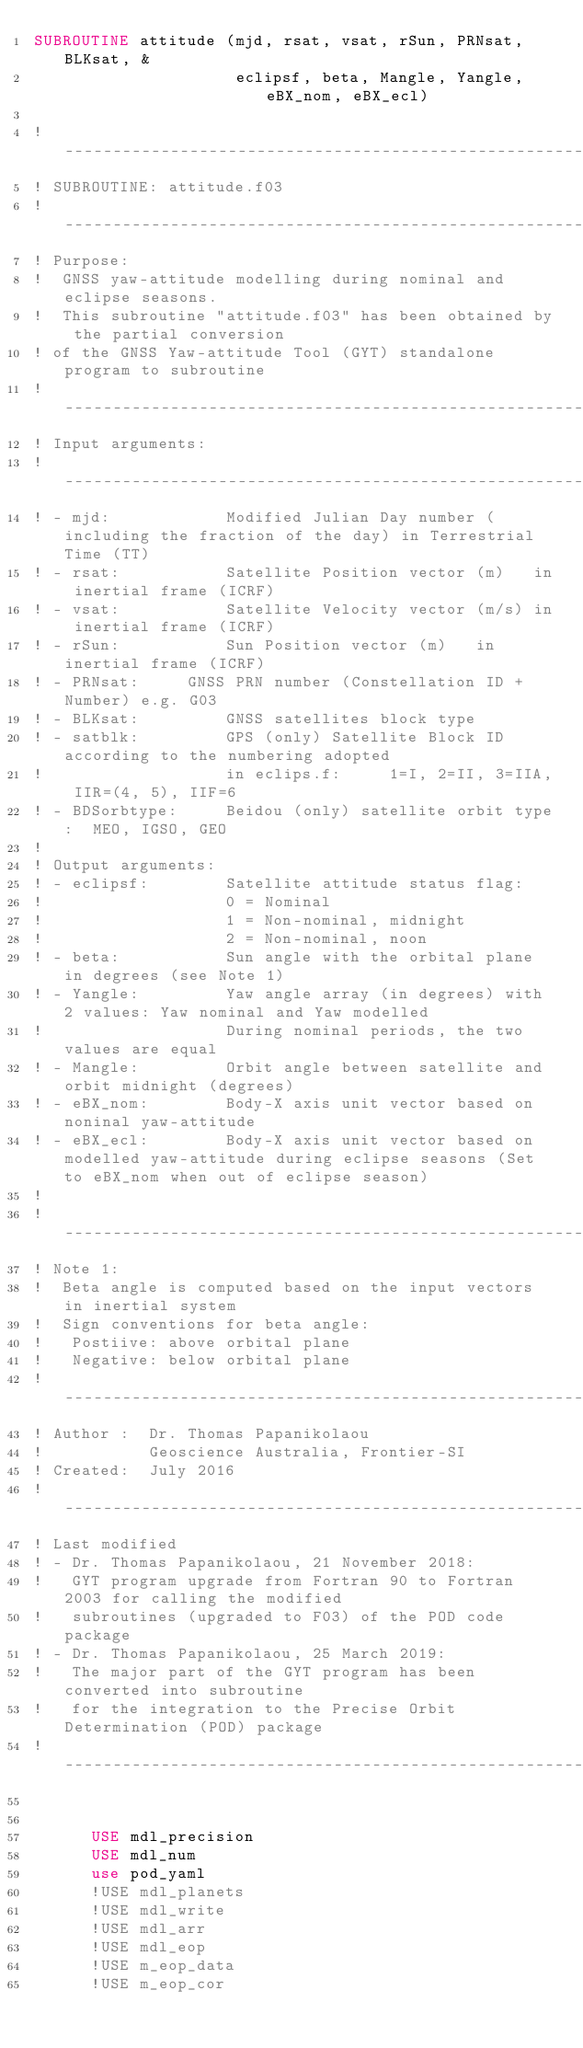Convert code to text. <code><loc_0><loc_0><loc_500><loc_500><_FORTRAN_>SUBROUTINE attitude (mjd, rsat, vsat, rSun, PRNsat, BLKsat, & 
                     eclipsf, beta, Mangle, Yangle, eBX_nom, eBX_ecl)

! ----------------------------------------------------------------------
! SUBROUTINE: attitude.f03 
! ----------------------------------------------------------------------
! Purpose:
!  GNSS yaw-attitude modelling during nominal and eclipse seasons.
!  This subroutine "attitude.f03" has been obtained by the partial conversion
! of the GNSS Yaw-attitude Tool (GYT) standalone program to subroutine  
! ----------------------------------------------------------------------
! Input arguments:
! ----------------------------------------------------------------------
! - mjd:			Modified Julian Day number (including the fraction of the day) in Terrestrial Time (TT)
! - rsat:			Satellite Position vector (m)   in inertial frame (ICRF)
! - vsat:			Satellite Velocity vector (m/s) in inertial frame (ICRF)
! - rSun:			Sun Position vector (m)   in inertial frame (ICRF)
! - PRNsat:		GNSS PRN number (Constellation ID + Number) e.g. G03
! - BLKsat:			GNSS satellites block type
! - satblk:			GPS (only) Satellite Block ID according to the numbering adopted 
!					in eclips.f:     1=I, 2=II, 3=IIA, IIR=(4, 5), IIF=6
! - BDSorbtype:		Beidou (only) satellite orbit type:  MEO, IGSO, GEO
!
! Output arguments:
! - eclipsf:		Satellite attitude status flag:
!					0 = Nominal
!					1 = Non-nominal, midnight
!					2 = Non-nominal, noon
! - beta:			Sun angle with the orbital plane in degrees (see Note 1)
! - Yangle: 		Yaw angle array (in degrees) with 2 values: Yaw nominal and Yaw modelled
!					During nominal periods, the two values are equal
! - Mangle:			Orbit angle between satellite and orbit midnight (degrees)
! - eBX_nom:		Body-X axis unit vector based on noninal yaw-attitude
! - eBX_ecl:		Body-X axis unit vector based on modelled yaw-attitude during eclipse seasons (Set to eBX_nom when out of eclipse season) 
!
! ----------------------------------------------------------------------
! Note 1:
!  Beta angle is computed based on the input vectors in inertial system
!  Sign conventions for beta angle:
!   Postiive: above orbital plane
!   Negative: below orbital plane  	
! ----------------------------------------------------------------------
! Author :	Dr. Thomas Papanikolaou
!			Geoscience Australia, Frontier-SI
! Created:	July 2016
! ----------------------------------------------------------------------
! Last modified
! - Dr. Thomas Papanikolaou, 21 November 2018:
!	GYT program upgrade from Fortran 90 to Fortran 2003 for calling the modified 
!   subroutines (upgraded to F03) of the POD code package 
! - Dr. Thomas Papanikolaou, 25 March 2019:
!   The major part of the GYT program has been converted into subroutine 
!   for the integration to the Precise Orbit Determination (POD) package  
! ----------------------------------------------------------------------


      USE mdl_precision
      USE mdl_num
      use pod_yaml
      !USE mdl_planets
      !USE mdl_write
      !USE mdl_arr
      !USE mdl_eop
      !USE m_eop_data
      !USE m_eop_cor</code> 